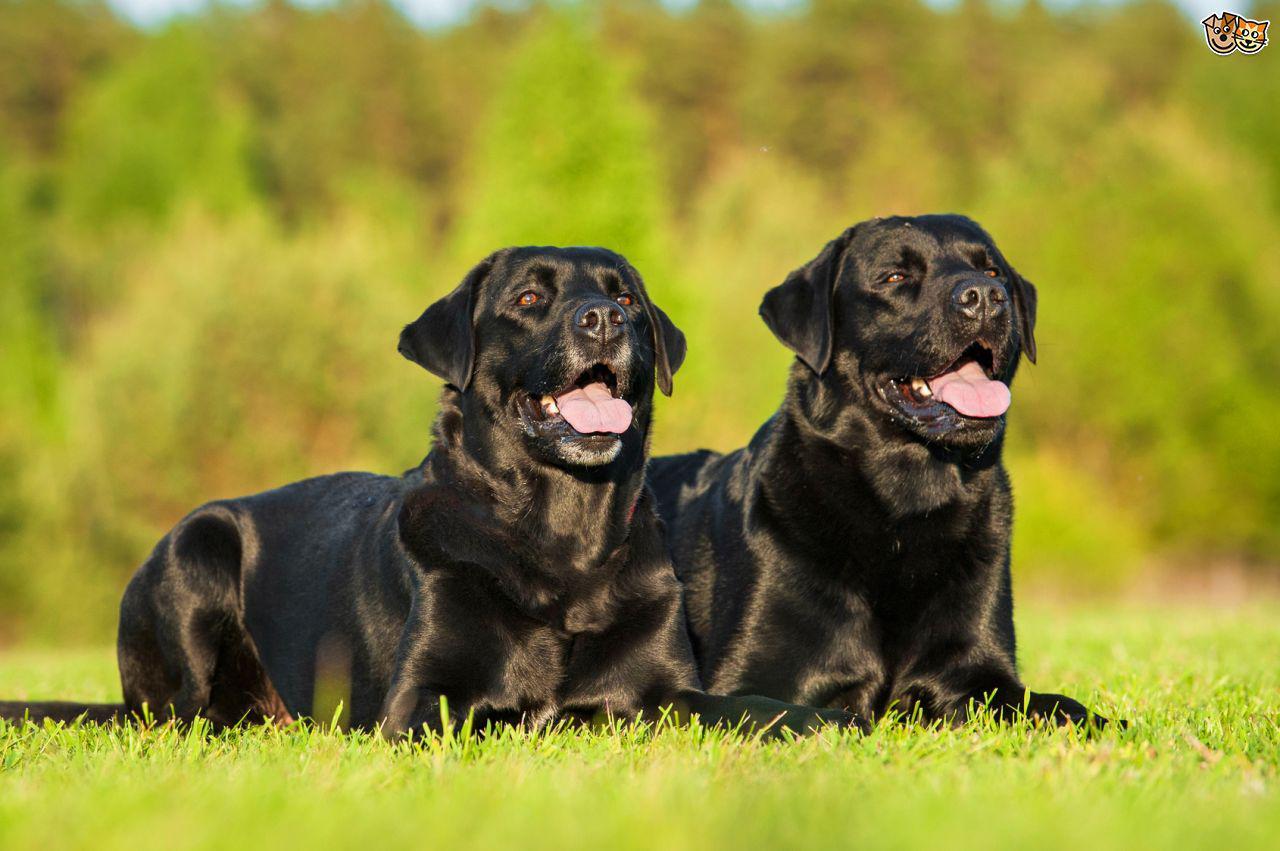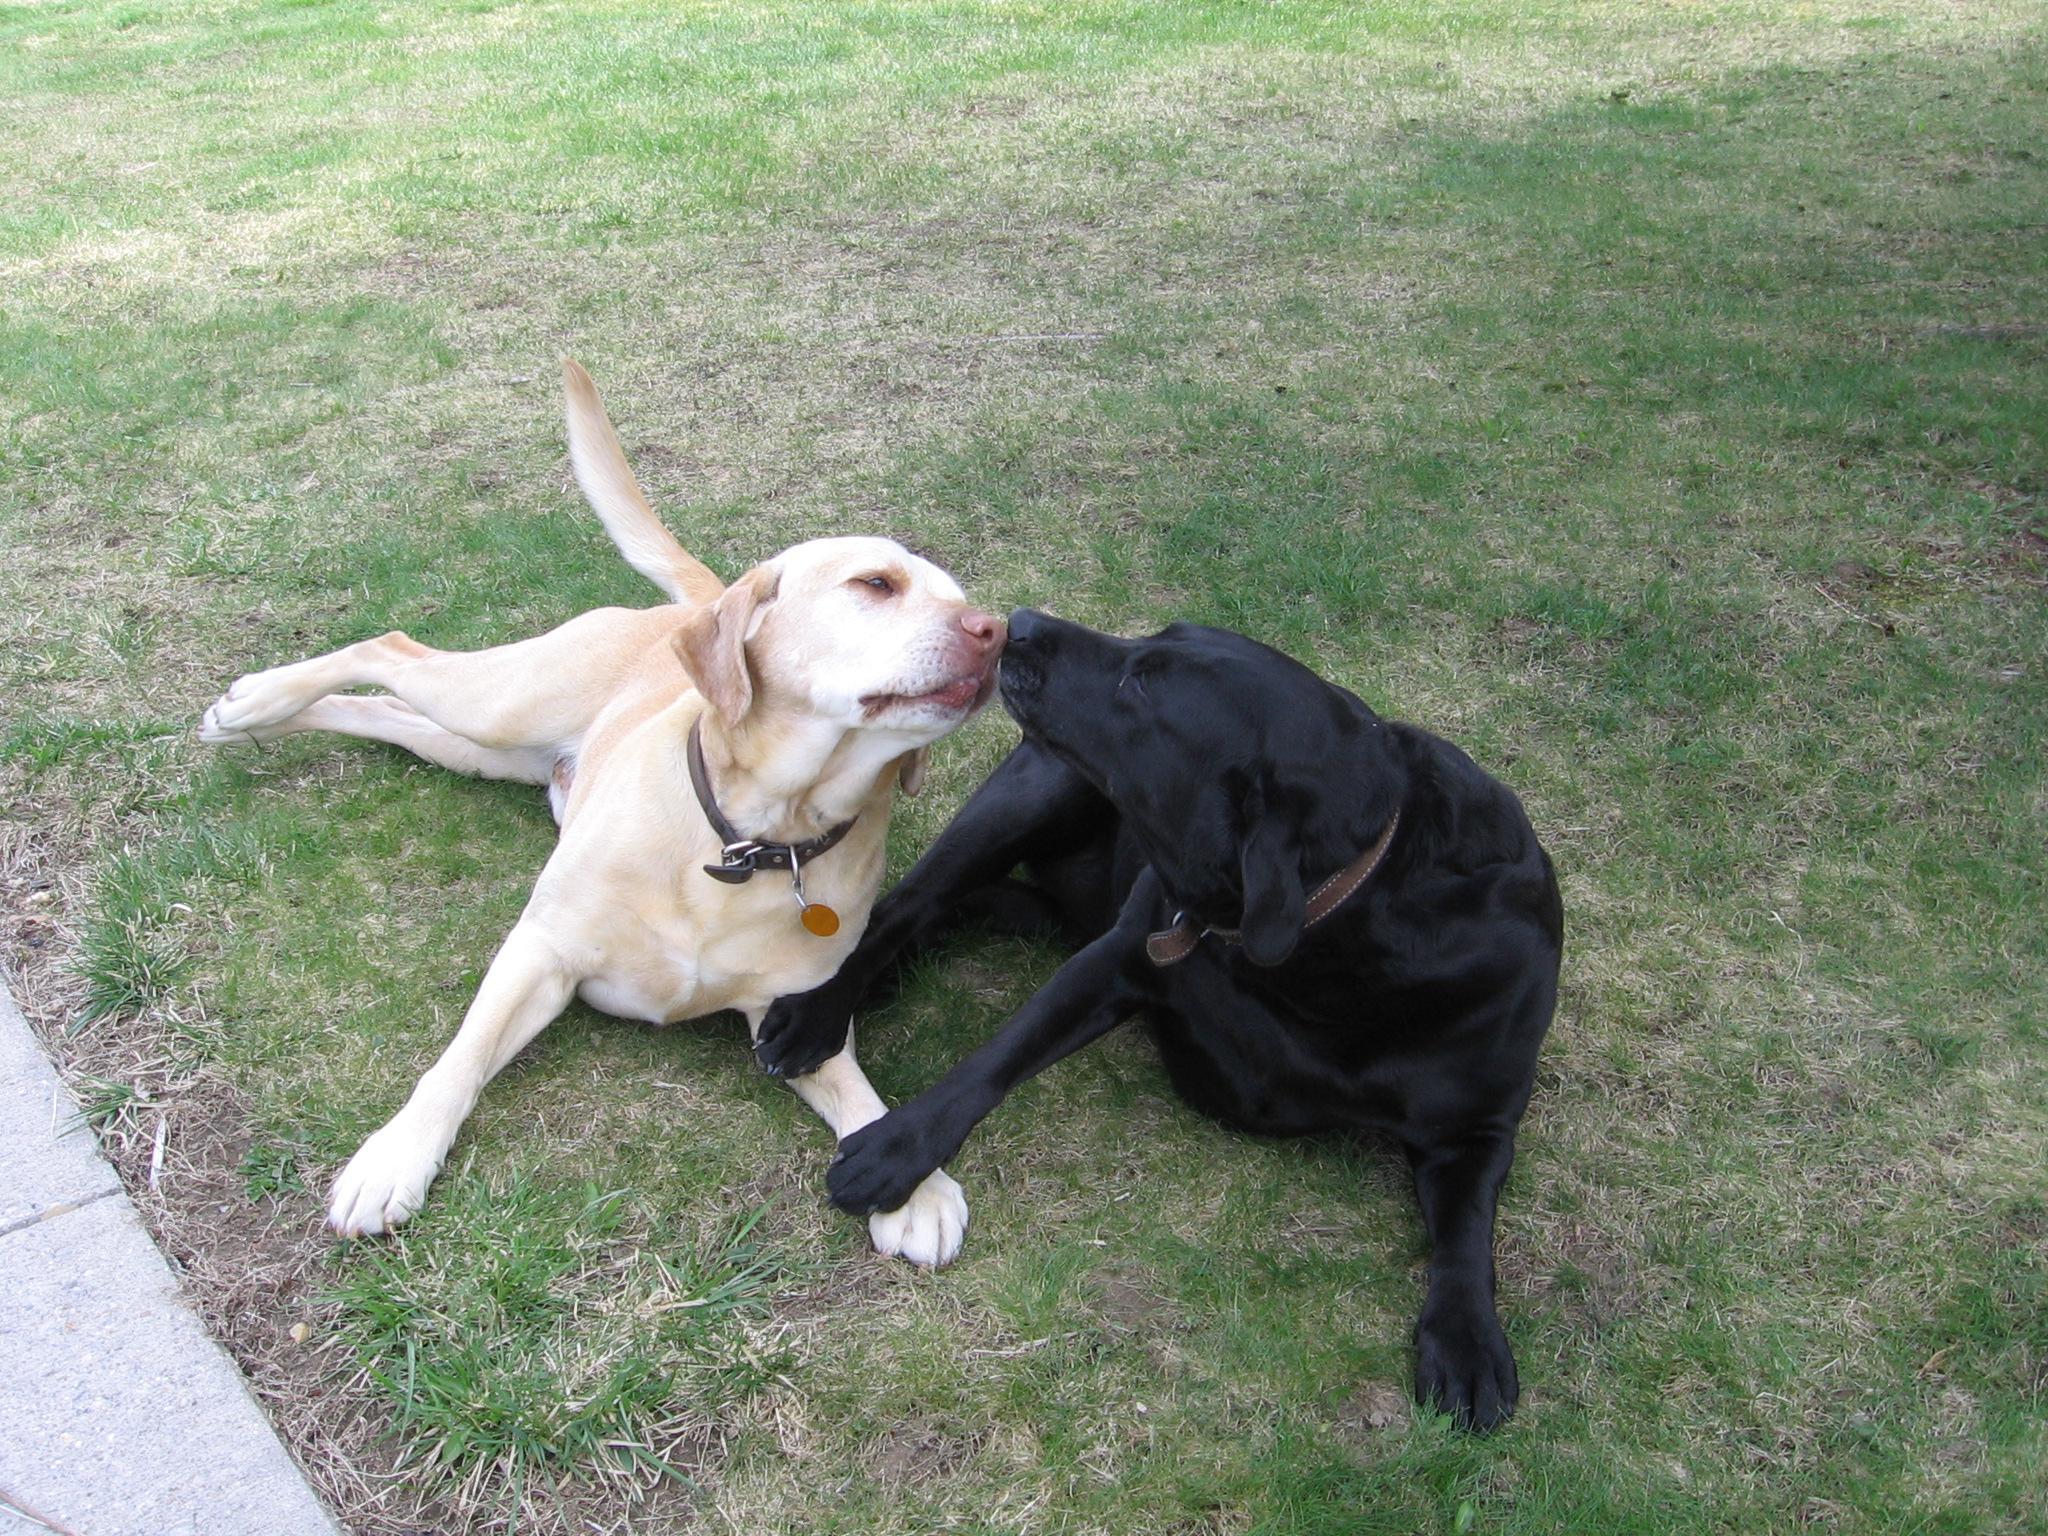The first image is the image on the left, the second image is the image on the right. Examine the images to the left and right. Is the description "There are three black dogs in the grass." accurate? Answer yes or no. Yes. The first image is the image on the left, the second image is the image on the right. Evaluate the accuracy of this statement regarding the images: "There are four dogs in total.". Is it true? Answer yes or no. Yes. 